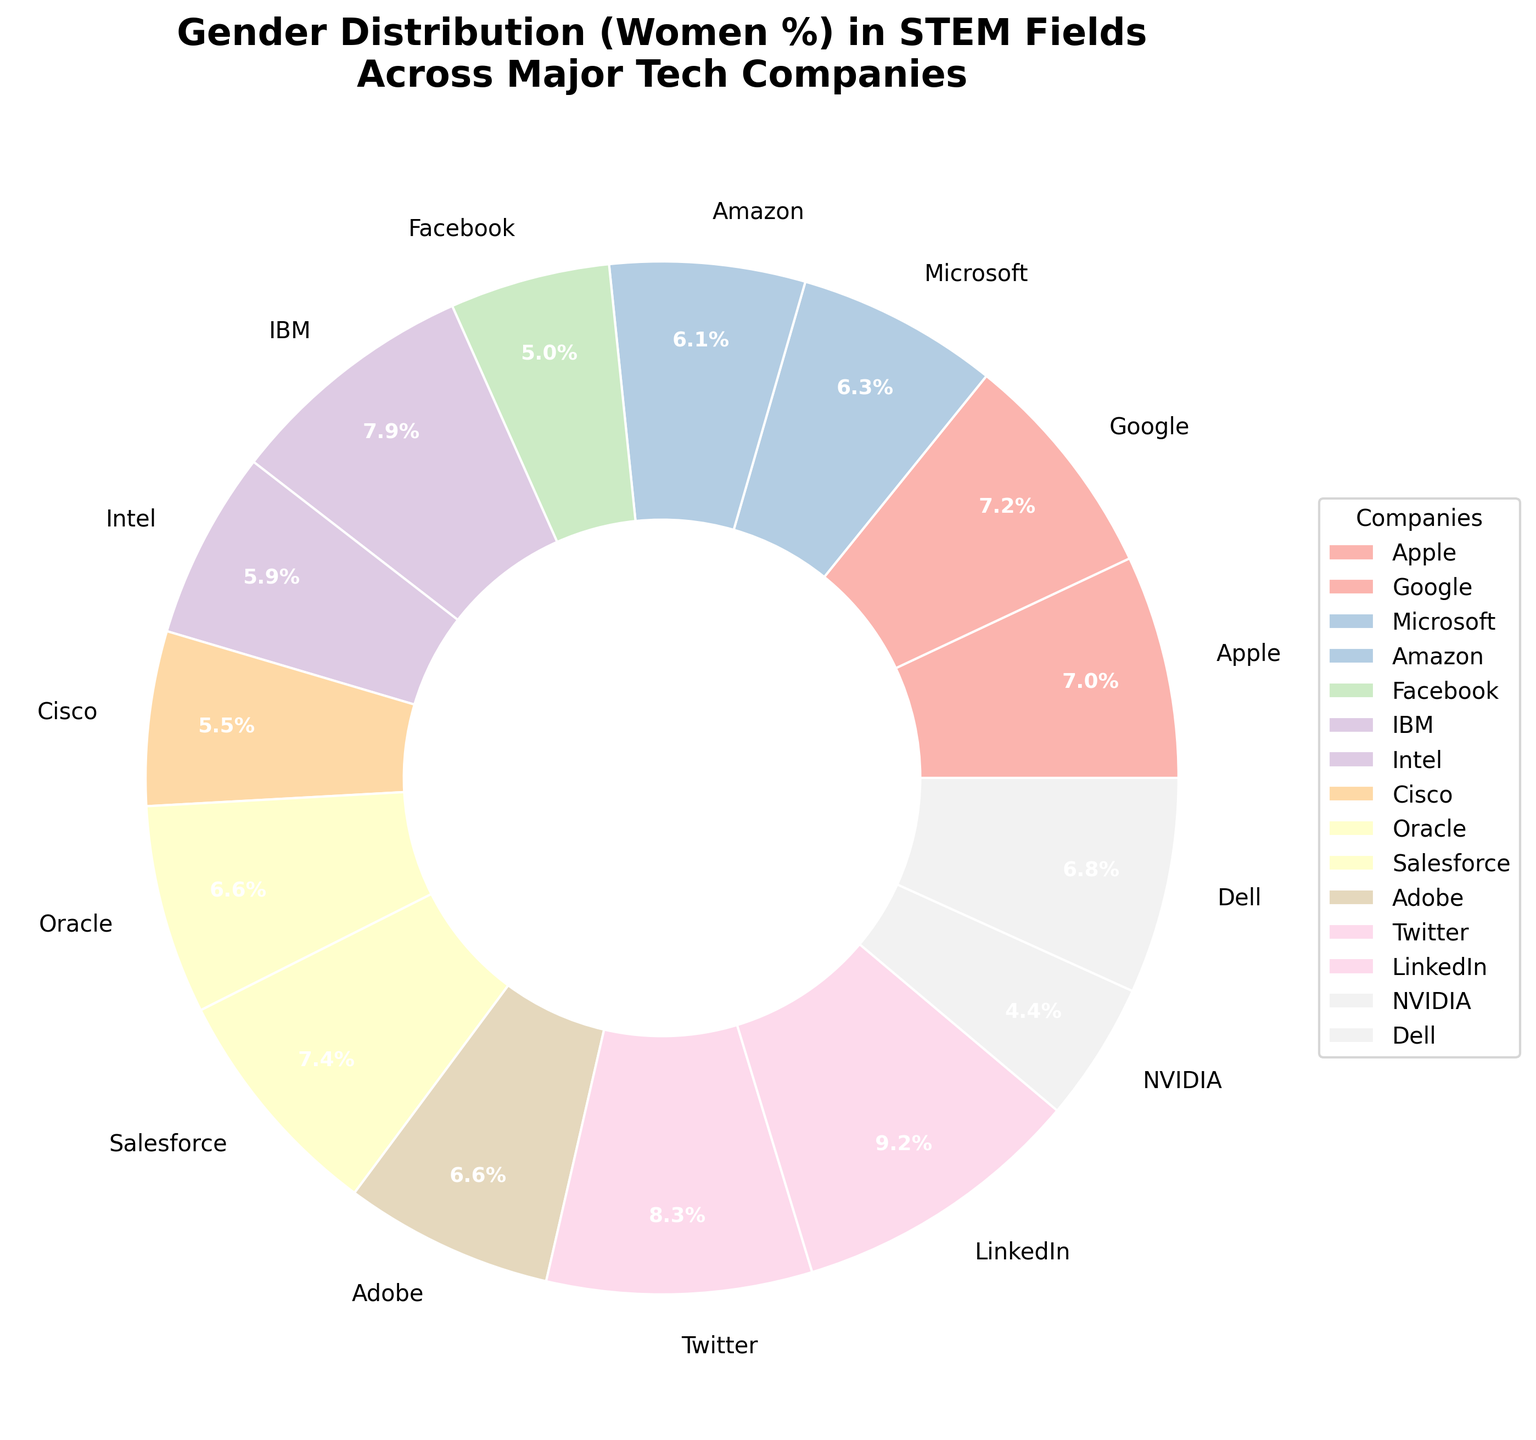Which company has the highest percentage of women in STEM fields? By examining the pie chart, we can see that each wedge corresponds to a company with its percentage labeled. The highest percentage is labeled at LinkedIn with 42%.
Answer: LinkedIn What is the difference in the percentage of women in STEM fields between Facebook and Twitter? To find the difference, look at the percentages for Facebook (23%) and Twitter (38%) and subtract the smaller value from the larger one: 38% - 23% = 15%.
Answer: 15% What is the average percentage of women in STEM fields across Microsoft, Oracle, and Intel? Add the percentages for Microsoft (29%), Oracle (30%), and Intel (27%) and divide by the number of companies, which is 3: (29 + 30 + 27) / 3 = 28.67%.
Answer: 28.67% Which company has the closest percentage to Apple's percentage of women in STEM fields? Apple's percentage is 32%. By looking at the nearby percentages on the pie chart, we notice Google is at 33%, which is closest to 32%.
Answer: Google How many companies have a percentage of women in STEM fields above 30%? Count the companies with percentages labeled above 30%: Apple (32%), Google (33%), IBM (36%), Salesforce (34%), LinkedIn (42%), Adobe (30%), Twitter (38%), and Dell (31%). This gives us 8 companies.
Answer: 8 Are there more companies with a percentage of women in STEM fields above 30% or below 30%? First, count the companies above 30% (8 companies) and those below 30% (7 companies: Microsoft, Amazon, Facebook, Intel, Cisco, NVIDIA, Oracle). There are more companies above 30%.
Answer: Above 30% What is the combined percentage of women in STEM fields for Google and Salesforce? Add the percentages for Google (33%) and Salesforce (34%): 33% + 34% = 67%.
Answer: 67% Which company has a lower percentage of women in STEM fields, Amazon or NVIDIA? By looking at the labels on the pie chart, the percentage for Amazon is 28% and for NVIDIA is 20%. NVIDIA has a lower percentage.
Answer: NVIDIA Which company's wedge has the second-largest size in the pie chart? The wedges' sizes correspond to the percentage values. LinkedIn at 42% is the largest, and Twitter at 38% is the second-largest.
Answer: Twitter 